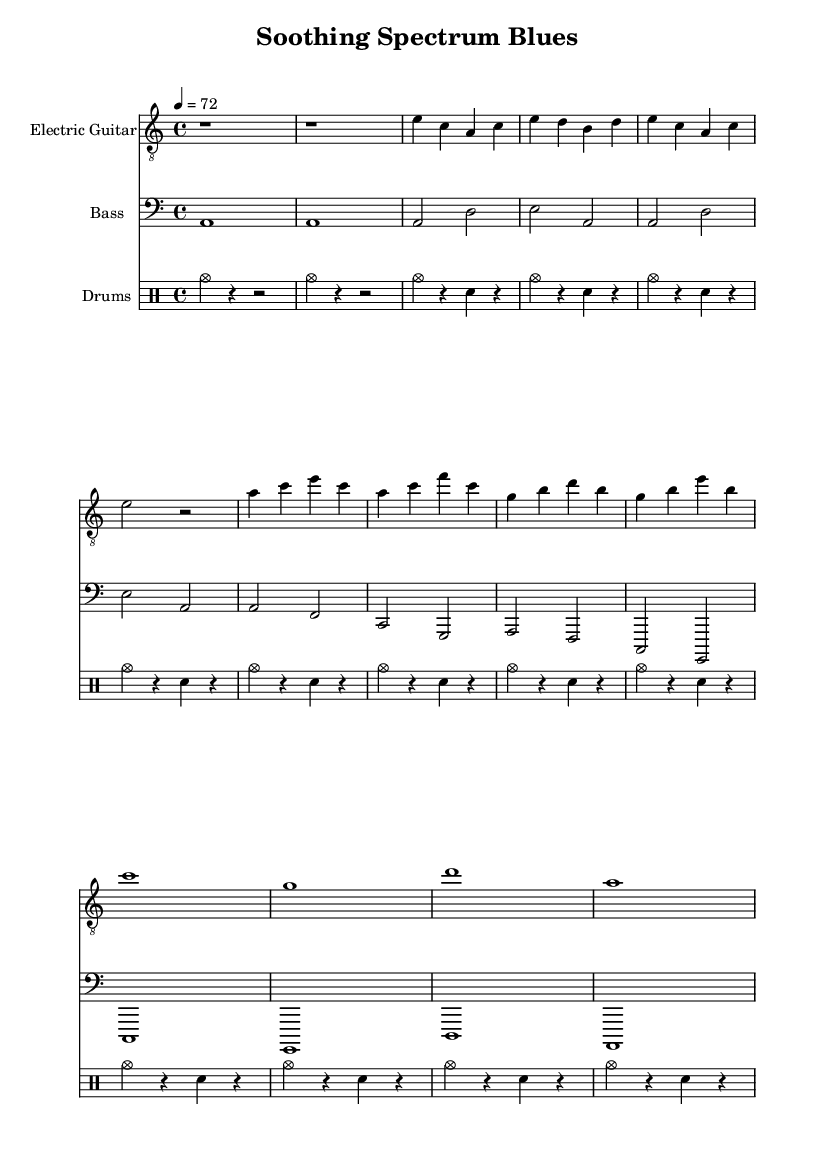What is the key signature of this music? The key signature is indicated at the beginning of the score, where it shows that the piece is in A minor, which has no sharps or flats.
Answer: A minor What is the time signature of the piece? The time signature is located next to the key signature, showing that this piece is in 4/4 time, which means there are four beats in each measure.
Answer: 4/4 What is the tempo marking for this piece? The tempo marking appears near the start of the score, stating that the tempo is set at a quarter note equals 72 beats per minute.
Answer: 72 What instruments are used in this piece? The instruments are noted at the beginning of each staff: Electric Guitar, Bass, and Drums are specified as the three parts of the arrangement.
Answer: Electric Guitar, Bass, Drums In which section does the tempo remain consistent? The consistent tempo is found throughout the piece, as it is established at the beginning and does not change in any sections including the verses, chorus, and bridge.
Answer: All sections What kind of rhythm pattern is primarily used in the drum part? The drum part consists of consistent patterns, prominently featuring cymbals for the beats and snare hits in between, which is characteristic of the electric blues style.
Answer: Cymbals and snare 